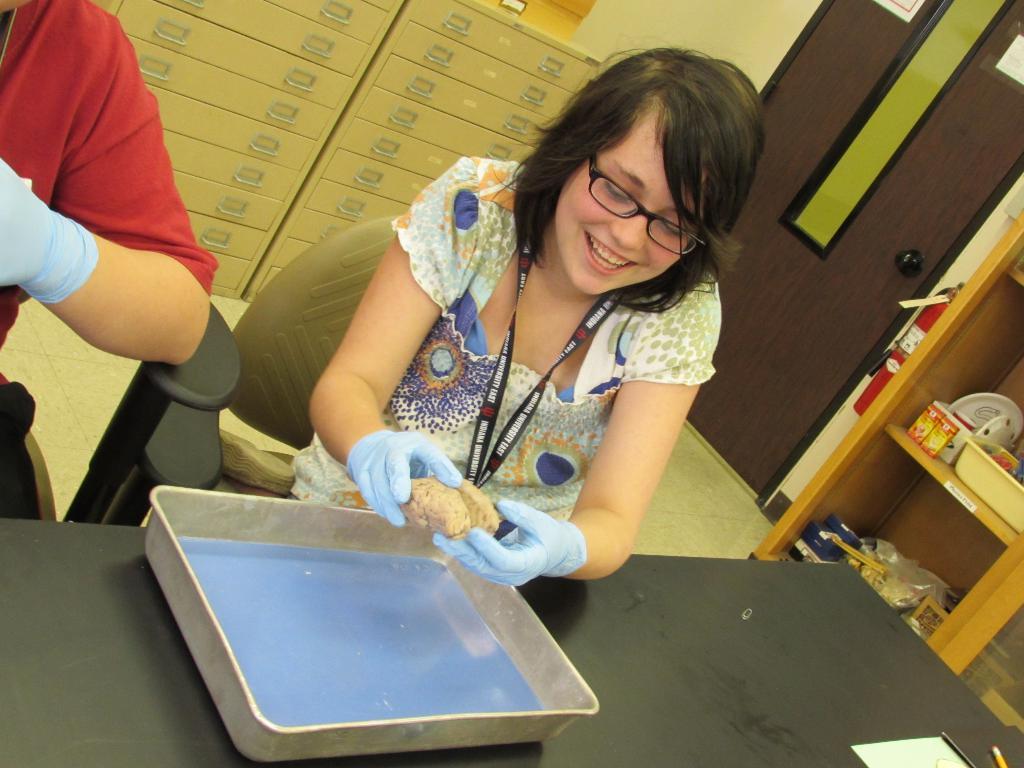Can you describe this image briefly? There is a woman sitting on the chair. She has spectacles and she is smiling. This is table. On the table there is a tray. Here we can see a person. On the background there are lockers. This is floor and there is a door. Here we can see a rack. 